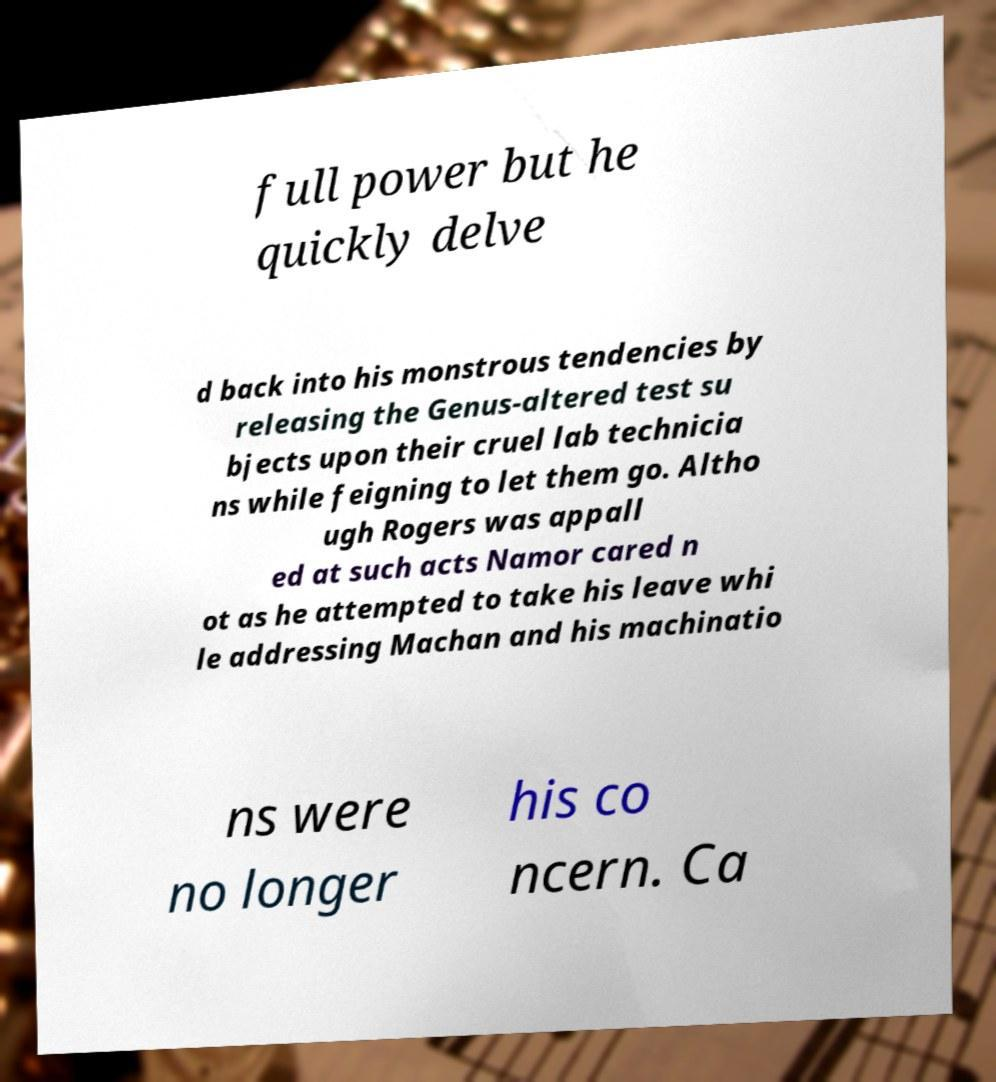Please identify and transcribe the text found in this image. full power but he quickly delve d back into his monstrous tendencies by releasing the Genus-altered test su bjects upon their cruel lab technicia ns while feigning to let them go. Altho ugh Rogers was appall ed at such acts Namor cared n ot as he attempted to take his leave whi le addressing Machan and his machinatio ns were no longer his co ncern. Ca 